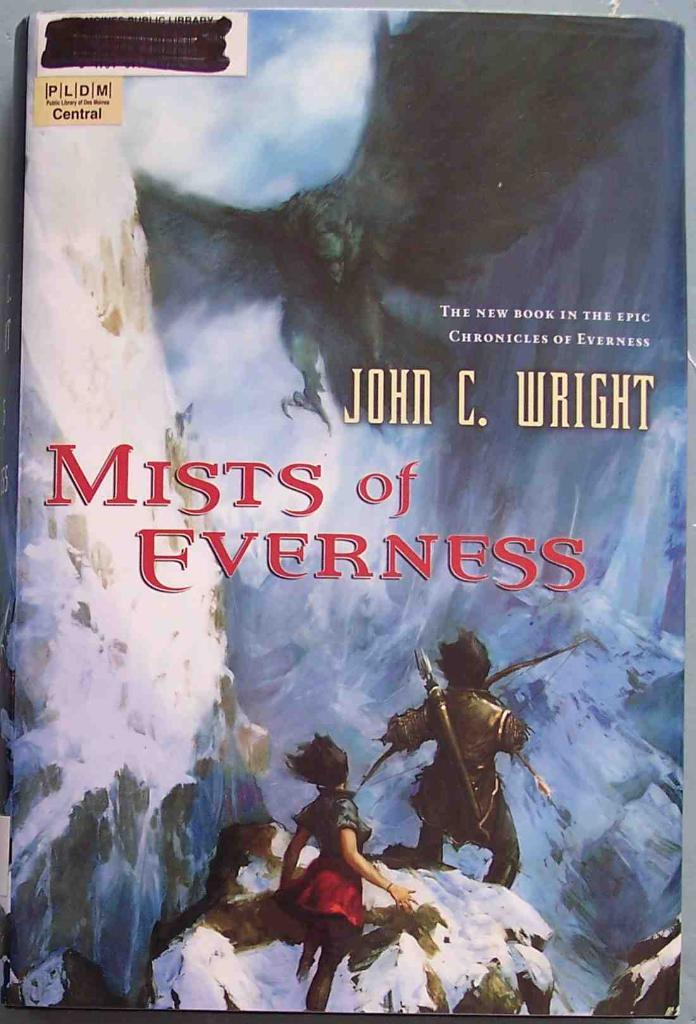What is the main object in the image? There is a book in the image. What can be seen on the cover page of the book? The cover page of the book has animated pictures. Is there any text on the book cover? Yes, there is text on the cover page of the book. Is there a cobweb visible on the book in the image? There is no mention of a cobweb in the provided facts, so we cannot determine if one is present in the image. 